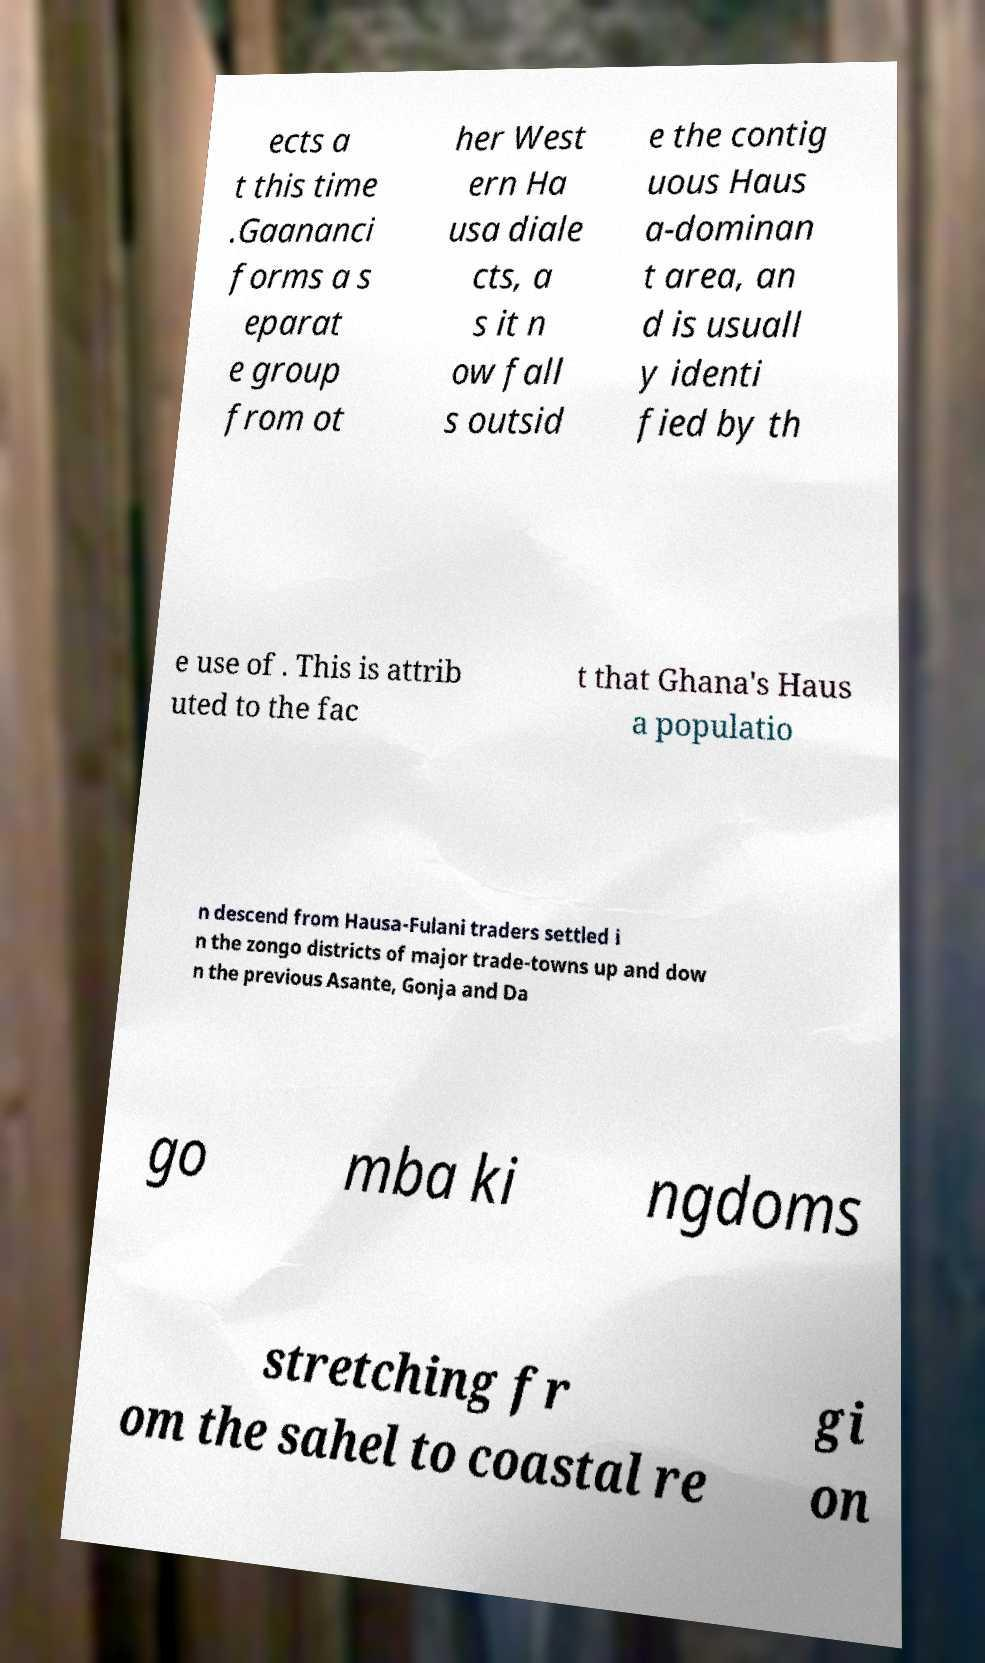Please identify and transcribe the text found in this image. ects a t this time .Gaananci forms a s eparat e group from ot her West ern Ha usa diale cts, a s it n ow fall s outsid e the contig uous Haus a-dominan t area, an d is usuall y identi fied by th e use of . This is attrib uted to the fac t that Ghana's Haus a populatio n descend from Hausa-Fulani traders settled i n the zongo districts of major trade-towns up and dow n the previous Asante, Gonja and Da go mba ki ngdoms stretching fr om the sahel to coastal re gi on 